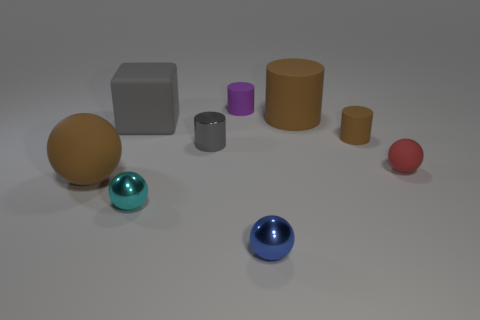Is the number of big matte cubes greater than the number of gray balls?
Offer a very short reply. Yes. What number of spheres are both behind the small cyan thing and in front of the cyan shiny object?
Provide a succinct answer. 0. How many big matte objects are behind the ball on the left side of the gray rubber cube?
Ensure brevity in your answer.  2. What number of things are small balls that are to the left of the purple cylinder or cylinders that are on the right side of the small gray object?
Ensure brevity in your answer.  4. What is the material of the small blue object that is the same shape as the cyan thing?
Ensure brevity in your answer.  Metal. What number of objects are either tiny cylinders that are on the right side of the small blue object or big blue blocks?
Make the answer very short. 1. The gray object that is the same material as the brown sphere is what shape?
Ensure brevity in your answer.  Cube. What number of big gray matte objects have the same shape as the red matte object?
Offer a very short reply. 0. What material is the purple cylinder?
Offer a very short reply. Rubber. Does the metallic cylinder have the same color as the small matte ball that is right of the tiny purple matte cylinder?
Provide a short and direct response. No. 